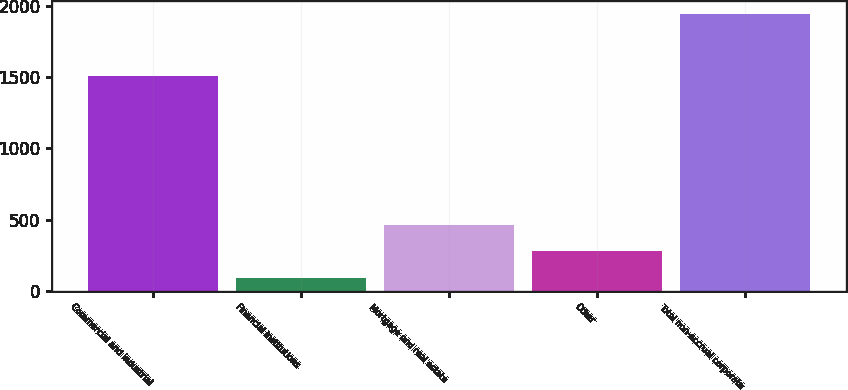<chart> <loc_0><loc_0><loc_500><loc_500><bar_chart><fcel>Commercial and industrial<fcel>Financial institutions<fcel>Mortgage and real estate<fcel>Other<fcel>Total non-accrual corporate<nl><fcel>1506<fcel>92<fcel>462<fcel>277<fcel>1942<nl></chart> 